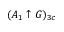Convert formula to latex. <formula><loc_0><loc_0><loc_500><loc_500>( A _ { 1 } \uparrow G ) _ { 3 c }</formula> 